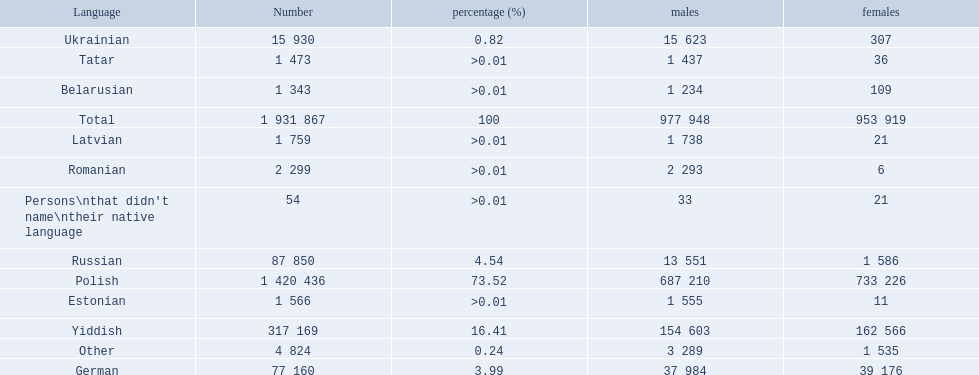Which languages are spoken by more than 50,000 people? Polish, Yiddish, Russian, German. Of these languages, which ones are spoken by less than 15% of the population? Russian, German. Of the remaining two, which one is spoken by 37,984 males? German. 